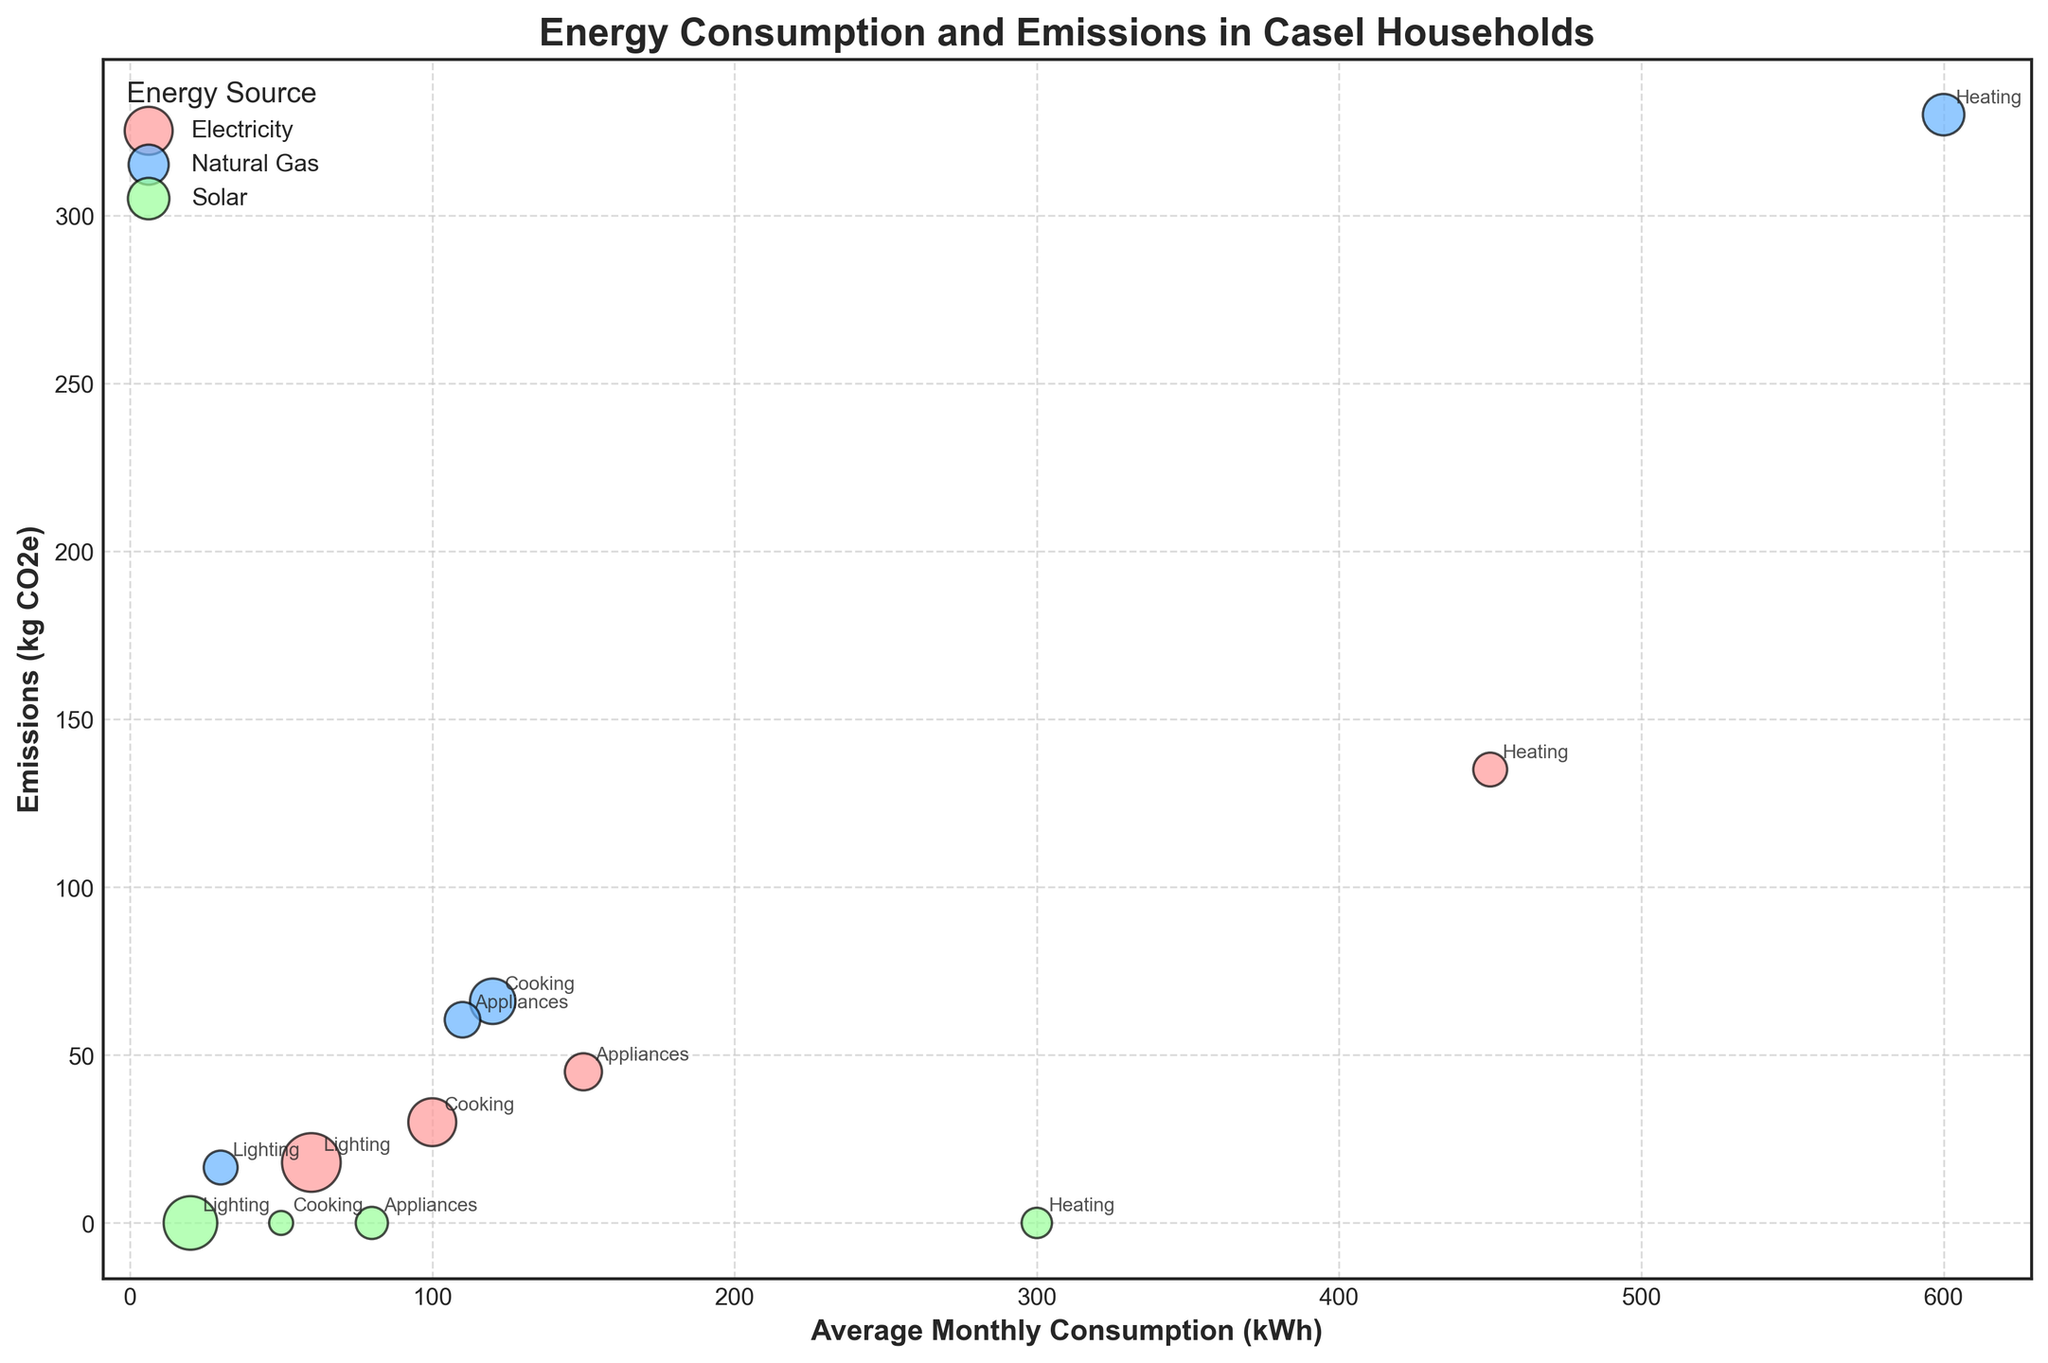How many energy sources are represented in the figure? By looking at the legend, we see that the figure includes three distinct energy sources: Electricity, Natural Gas, and Solar.
Answer: 3 Which usage category has the highest "Average Monthly Consumption (kWh)" for Natural Gas? Locate the bubbles colored for Natural Gas, then look for the one with the highest x-axis value (Average Monthly Consumption). The bubble for Heating has the highest value.
Answer: Heating How many households use Solar energy for Lighting? Find the bubble representing Solar energy and Lighting, which can be identified by its color (for Solar) and label (for Lighting). The size of this bubble indicates the quantity: 25 households.
Answer: 25 Compare the emissions from Electricity and Natural Gas for Cooking. Which one is higher and by how much? Locate the bubbles for Cooking under Electricity and Natural Gas. The y-axis values (Emissions in kg CO2e) are 30 for Electricity and 66 for Natural Gas. The difference is 66 - 30 = 36 kg CO2e.
Answer: Natural Gas by 36 kg CO2e What is the total number of households using Natural Gas for all usage categories? Add the sizes of all the Natural Gas bubbles: Heating (15), Cooking (18), Lighting (10), and Appliances (11). Summing these gives 15 + 18 + 10 + 11 = 54 households.
Answer: 54 Which energy source results in zero emissions and for which usage categories? Locate the bubbles with an emissions value of 0, which correspond to Solar energy (green bubbles). The labels of these bubbles are Heating, Cooking, and Lighting.
Answer: Solar for Heating, Cooking, and Lighting Between Electricity and Solar for Appliances, which has a higher average monthly consumption and by how much? Identify the bubbles for Appliances under Electricity and Solar. The x-axis values (Average Monthly Consumption) are 150 for Electricity and 80 for Solar. The difference is 150 - 80 = 70 kWh.
Answer: Electricity by 70 kWh Which usage category for Solar has the smallest household representation? Look for the smallest bubble among Solar energy category labels. The label with the smallest size (households count) is Cooking with 5 households.
Answer: Cooking What is the average emissions of all usage categories for Natural Gas? Find the y-axis values (Emissions) for all Natural Gas usage categories: Heating (330), Cooking (66), Lighting (16.5), and Appliances (60.5). Calculate the average: (330 + 66 + 16.5 + 60.5) / 4 = 118.25 kg CO2e.
Answer: 118.25 kg CO2e 